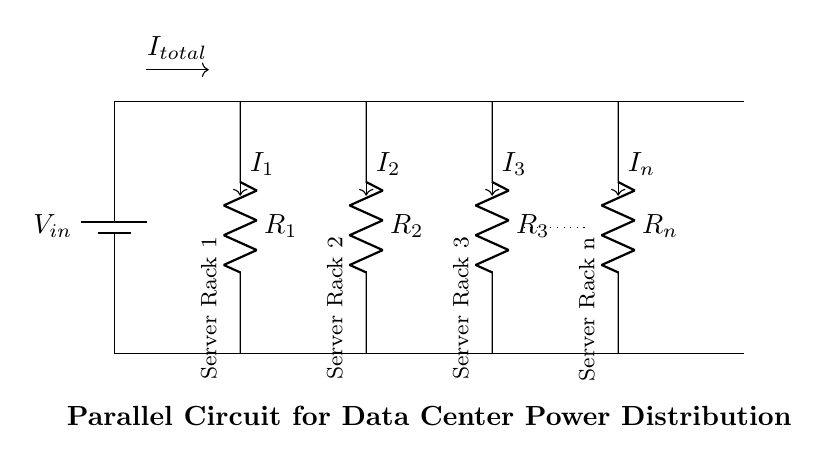What is the input voltage of the circuit? The input voltage is labeled as V_in, which is connected to the main power source.
Answer: V_in How many server racks are shown in the diagram? There are four server racks explicitly labeled in the circuit, and one of them indicates the presence of more racks with a dotted line.
Answer: Four What do R_1, R_2, R_3, and R_n represent in the circuit? R_1, R_2, R_3, and R_n denote the resistances connected to each server rack, indicating their individual power consumption.
Answer: Resistors What is the relationship between the total current and the individual currents? The total current, I_total, is the sum of all individual currents, I_1, I_2, I_3, and I_n, illustrating the principle of parallel circuits where all branches share the same voltage.
Answer: Sum If one server rack fails, what happens to the others? In a parallel circuit, if one server rack fails, the others continue to operate since they are independently connected across the same voltage source.
Answer: They continue to operate 